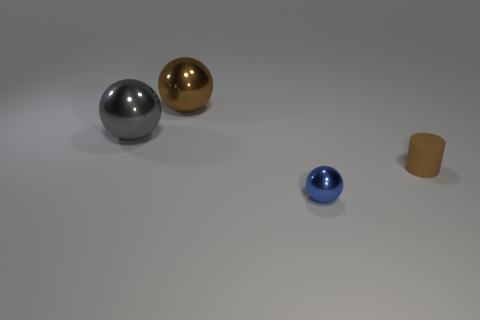How many other objects are there of the same color as the small rubber object?
Offer a terse response. 1. Is the number of brown spheres that are in front of the brown matte cylinder less than the number of large green matte spheres?
Your response must be concise. No. The metallic thing that is in front of the gray ball that is to the left of the small thing that is in front of the small matte object is what color?
Keep it short and to the point. Blue. Is there any other thing that is made of the same material as the gray sphere?
Your answer should be very brief. Yes. The brown metal thing that is the same shape as the blue shiny thing is what size?
Your answer should be compact. Large. Is the number of tiny matte cylinders that are to the left of the big brown sphere less than the number of small cylinders in front of the cylinder?
Your answer should be compact. No. There is a metal thing that is both in front of the brown ball and behind the small blue object; what is its shape?
Your answer should be compact. Sphere. The blue sphere that is the same material as the big gray ball is what size?
Your response must be concise. Small. Is the color of the cylinder the same as the large shiny sphere that is right of the large gray object?
Provide a short and direct response. Yes. There is a thing that is both behind the small blue metallic ball and on the right side of the brown shiny thing; what material is it?
Your answer should be compact. Rubber. 